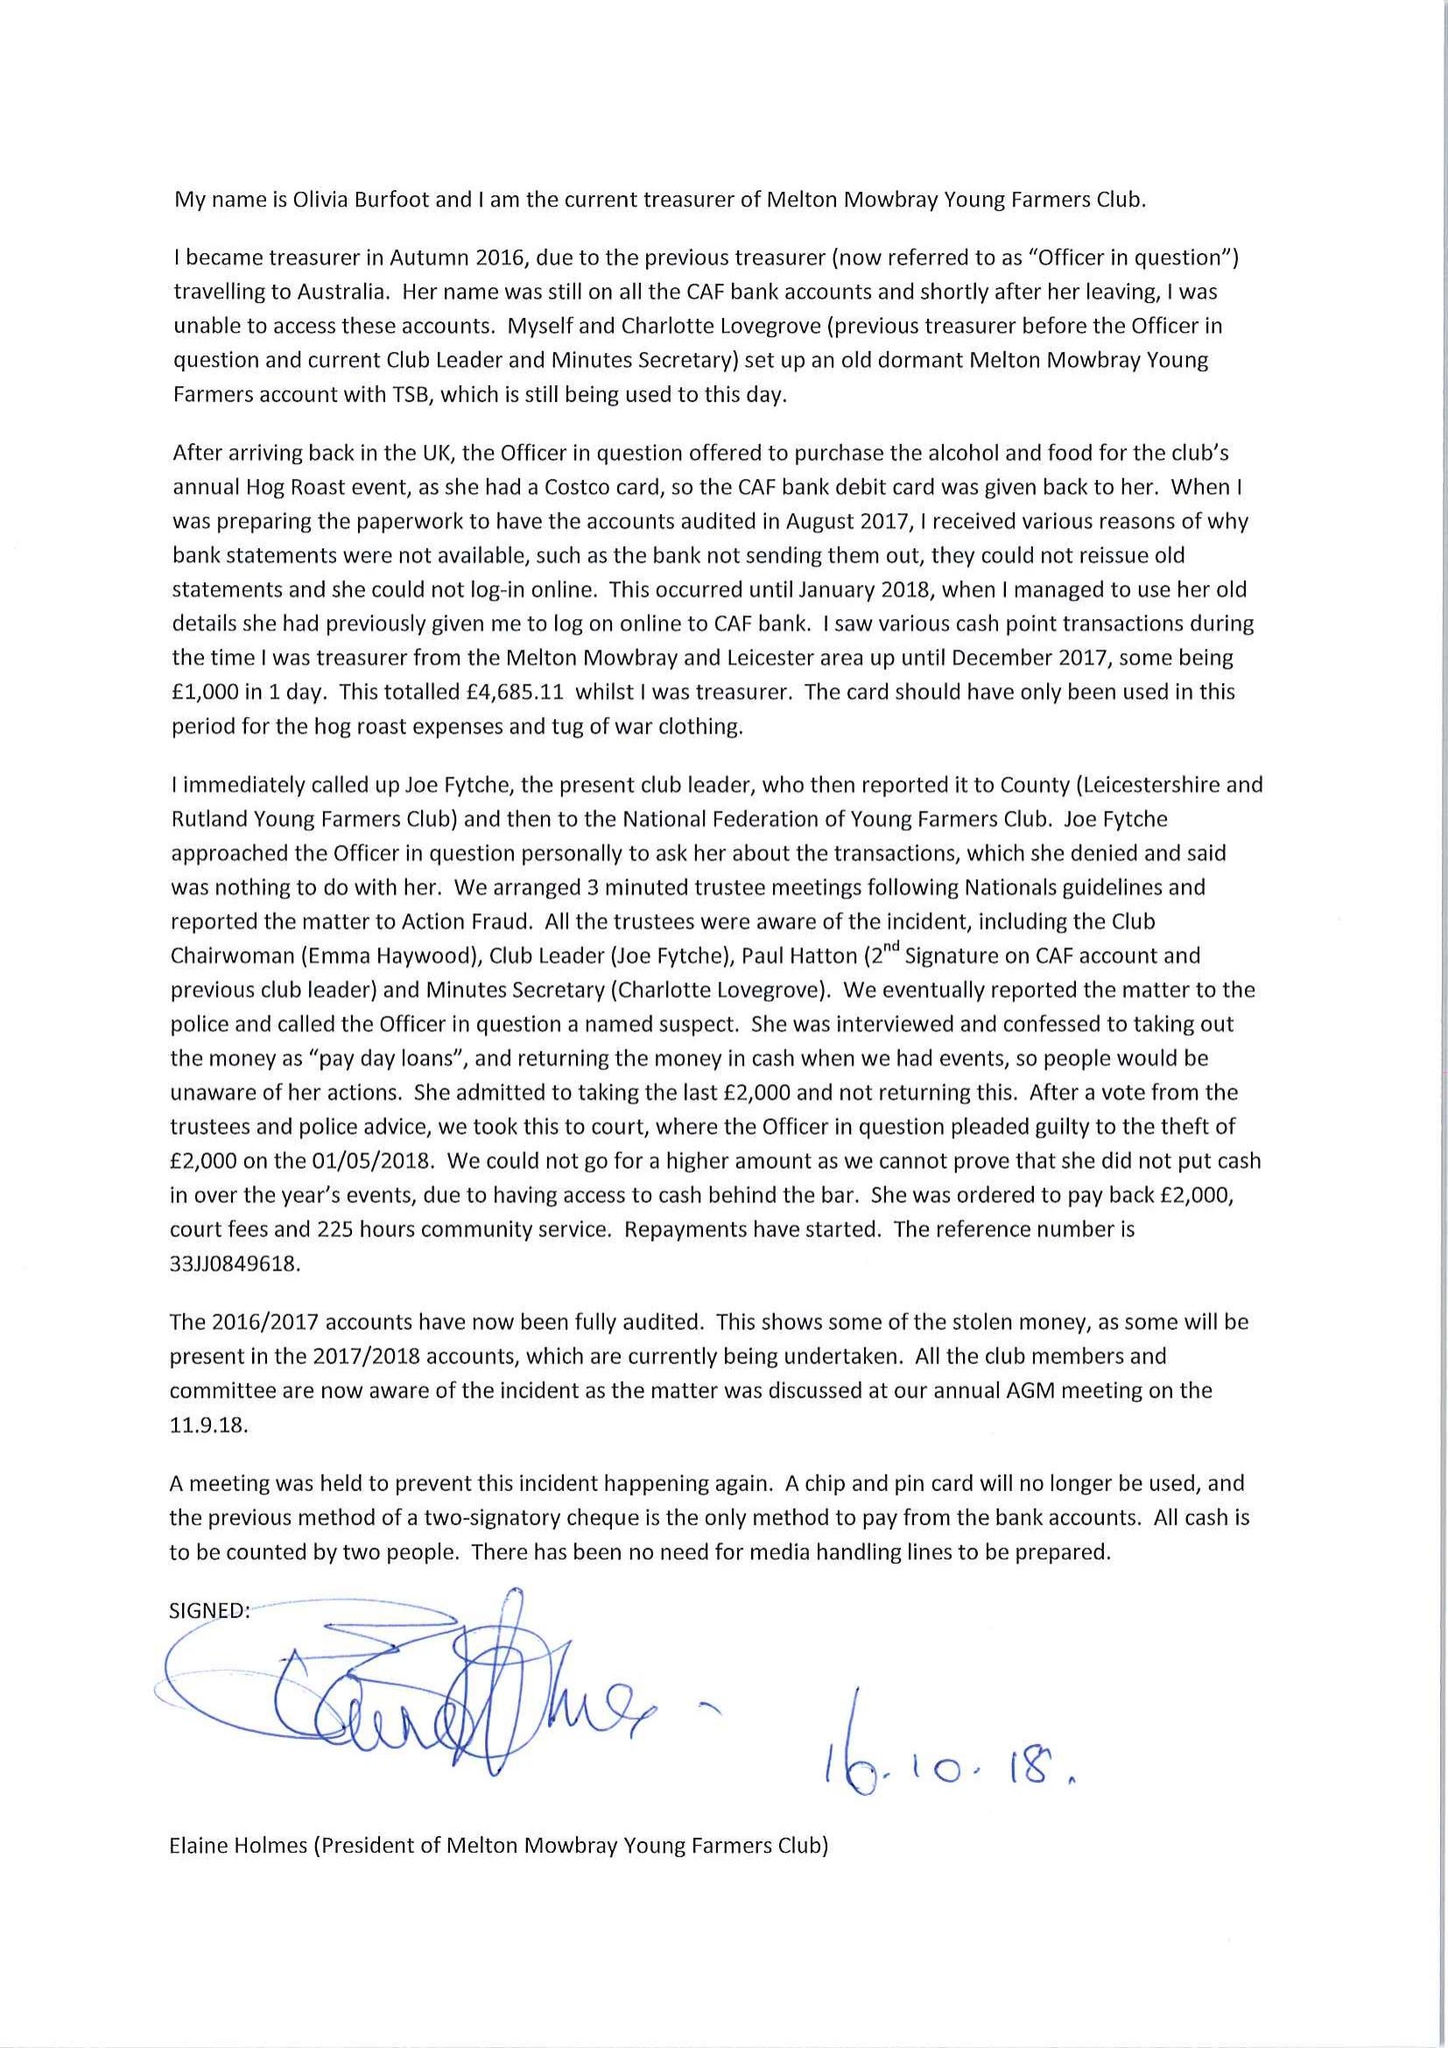What is the value for the address__postcode?
Answer the question using a single word or phrase. LE14 2LH 